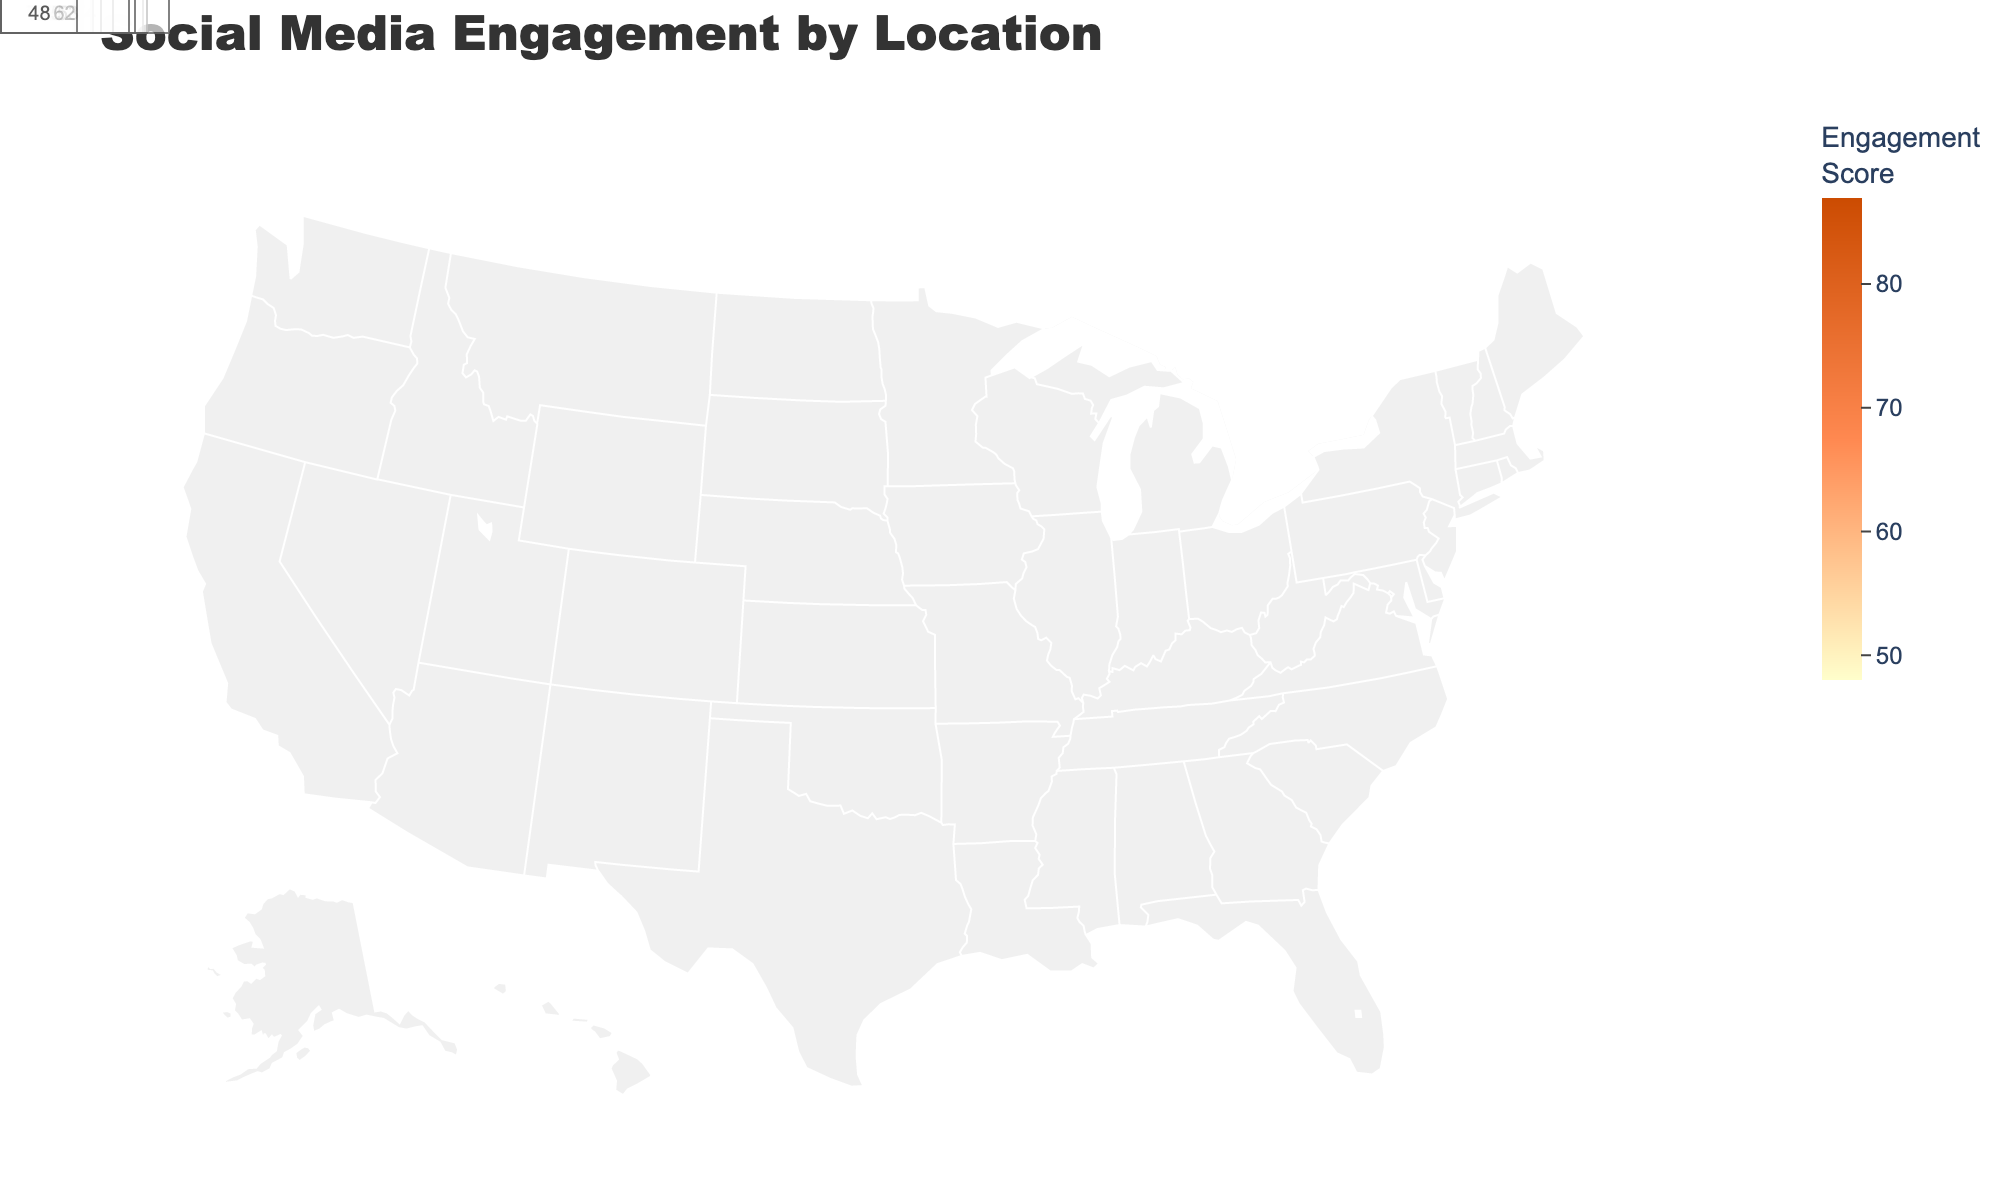What's the highest engagement score and in which location? The figure shows each city's engagement score. The highest engagement score is 87 in New York City.
Answer: 87 in New York City What's the average engagement score across all locations? Sum all the engagement scores and divide by the number of locations. (87 + 72 + 65 + 58 + 79 + 83 + 76 + 69 + 74 + 61 + 63 + 57 + 52 + 68 + 59 + 71 + 55 + 53 + 62 + 48) / 20 = 67
Answer: 67 Which cities have engagement scores above 80? Identify cities with engagement scores greater than 80. These cities are New York City (87), San Francisco (83), and Miami (79).
Answer: New York City, San Francisco, Miami Compare the engagement scores of Los Angeles and Chicago. Which one is higher? Los Angeles has an engagement score of 72, while Chicago has a score of 65. Los Angeles has the higher score.
Answer: Los Angeles What is the total engagement score for the cities on the west coast (e.g., Los Angeles, San Francisco, Seattle)? Add the engagement scores for Los Angeles (72), San Francisco (83), and Seattle (76). The total is 72 + 83 + 76 = 231.
Answer: 231 What's the difference in engagement scores between the city with the highest score and the city with the lowest score? The highest score is 87 (New York City), and the lowest score is 48 (Detroit). The difference is 87 - 48 = 39.
Answer: 39 Which city has the lowest engagement score, and what is the score? The lowest engagement score visible in the figure is 48, which is in Detroit.
Answer: Detroit, 48 How many cities have engagement scores between 60 and 70? Identify cities within the range of 60 to 70. They are Boston (69), Washington D.C. (74 falls out of this range), and Atlanta (61). Note that scores like 74 that fall out of the specified range are excluded.
Answer: 3 Is there a pattern or trend in the geographic distribution of engagement scores? Examine the heatmap for any visible patterns. Higher engagement seems concentrated in populous cities, while medium-sized cities have moderately lower scores.
Answer: Higher in populous cities 